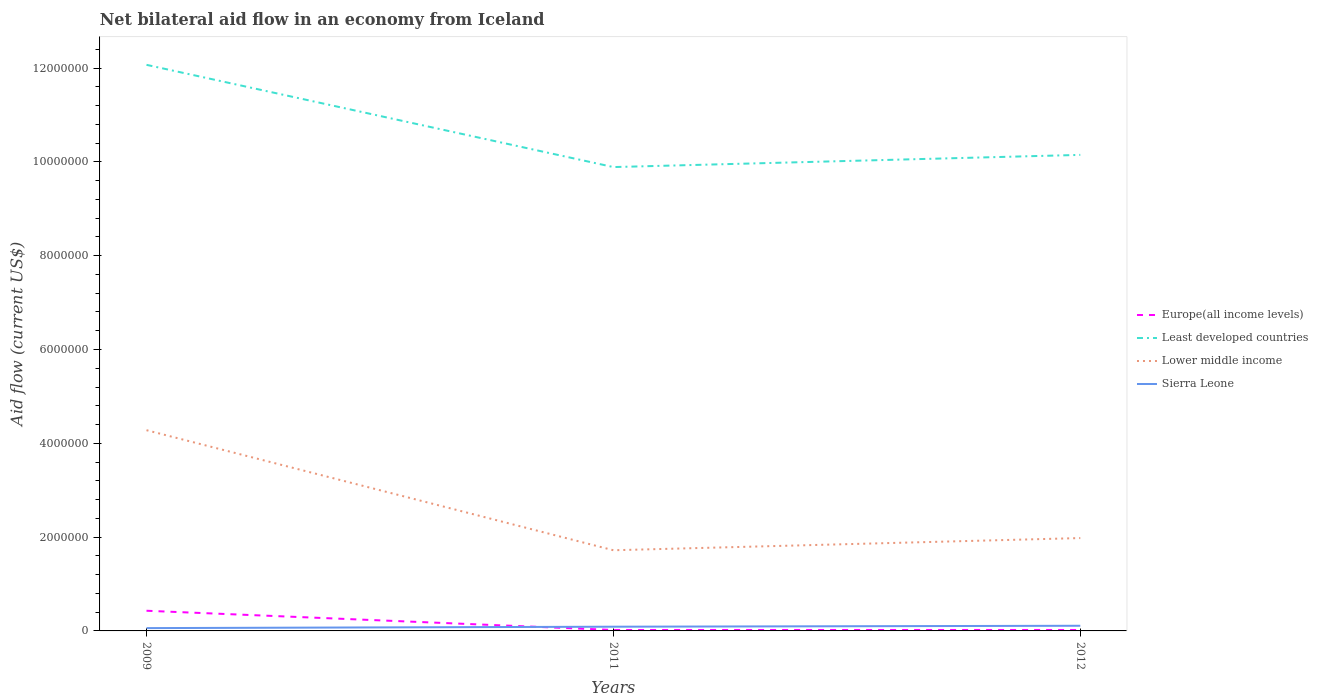Is the number of lines equal to the number of legend labels?
Offer a very short reply. Yes. What is the total net bilateral aid flow in Least developed countries in the graph?
Make the answer very short. 2.18e+06. What is the difference between the highest and the second highest net bilateral aid flow in Europe(all income levels)?
Give a very brief answer. 4.10e+05. What is the difference between the highest and the lowest net bilateral aid flow in Europe(all income levels)?
Ensure brevity in your answer.  1. How many years are there in the graph?
Make the answer very short. 3. Are the values on the major ticks of Y-axis written in scientific E-notation?
Your response must be concise. No. Does the graph contain any zero values?
Give a very brief answer. No. Does the graph contain grids?
Your answer should be compact. No. Where does the legend appear in the graph?
Ensure brevity in your answer.  Center right. How are the legend labels stacked?
Offer a terse response. Vertical. What is the title of the graph?
Make the answer very short. Net bilateral aid flow in an economy from Iceland. What is the label or title of the X-axis?
Offer a very short reply. Years. What is the Aid flow (current US$) in Europe(all income levels) in 2009?
Your answer should be compact. 4.30e+05. What is the Aid flow (current US$) in Least developed countries in 2009?
Give a very brief answer. 1.21e+07. What is the Aid flow (current US$) of Lower middle income in 2009?
Ensure brevity in your answer.  4.28e+06. What is the Aid flow (current US$) of Sierra Leone in 2009?
Ensure brevity in your answer.  6.00e+04. What is the Aid flow (current US$) of Europe(all income levels) in 2011?
Your answer should be very brief. 2.00e+04. What is the Aid flow (current US$) in Least developed countries in 2011?
Offer a very short reply. 9.89e+06. What is the Aid flow (current US$) of Lower middle income in 2011?
Offer a terse response. 1.72e+06. What is the Aid flow (current US$) of Sierra Leone in 2011?
Keep it short and to the point. 9.00e+04. What is the Aid flow (current US$) of Least developed countries in 2012?
Keep it short and to the point. 1.02e+07. What is the Aid flow (current US$) of Lower middle income in 2012?
Ensure brevity in your answer.  1.98e+06. Across all years, what is the maximum Aid flow (current US$) in Europe(all income levels)?
Provide a short and direct response. 4.30e+05. Across all years, what is the maximum Aid flow (current US$) in Least developed countries?
Your answer should be compact. 1.21e+07. Across all years, what is the maximum Aid flow (current US$) in Lower middle income?
Keep it short and to the point. 4.28e+06. Across all years, what is the maximum Aid flow (current US$) in Sierra Leone?
Your answer should be very brief. 1.10e+05. Across all years, what is the minimum Aid flow (current US$) of Least developed countries?
Your response must be concise. 9.89e+06. Across all years, what is the minimum Aid flow (current US$) in Lower middle income?
Provide a short and direct response. 1.72e+06. Across all years, what is the minimum Aid flow (current US$) in Sierra Leone?
Your response must be concise. 6.00e+04. What is the total Aid flow (current US$) in Least developed countries in the graph?
Keep it short and to the point. 3.21e+07. What is the total Aid flow (current US$) of Lower middle income in the graph?
Your response must be concise. 7.98e+06. What is the difference between the Aid flow (current US$) in Europe(all income levels) in 2009 and that in 2011?
Keep it short and to the point. 4.10e+05. What is the difference between the Aid flow (current US$) of Least developed countries in 2009 and that in 2011?
Ensure brevity in your answer.  2.18e+06. What is the difference between the Aid flow (current US$) of Lower middle income in 2009 and that in 2011?
Keep it short and to the point. 2.56e+06. What is the difference between the Aid flow (current US$) of Sierra Leone in 2009 and that in 2011?
Make the answer very short. -3.00e+04. What is the difference between the Aid flow (current US$) of Europe(all income levels) in 2009 and that in 2012?
Provide a short and direct response. 4.10e+05. What is the difference between the Aid flow (current US$) in Least developed countries in 2009 and that in 2012?
Your answer should be compact. 1.92e+06. What is the difference between the Aid flow (current US$) of Lower middle income in 2009 and that in 2012?
Your answer should be compact. 2.30e+06. What is the difference between the Aid flow (current US$) of Europe(all income levels) in 2011 and that in 2012?
Provide a short and direct response. 0. What is the difference between the Aid flow (current US$) of Europe(all income levels) in 2009 and the Aid flow (current US$) of Least developed countries in 2011?
Offer a terse response. -9.46e+06. What is the difference between the Aid flow (current US$) in Europe(all income levels) in 2009 and the Aid flow (current US$) in Lower middle income in 2011?
Provide a succinct answer. -1.29e+06. What is the difference between the Aid flow (current US$) of Europe(all income levels) in 2009 and the Aid flow (current US$) of Sierra Leone in 2011?
Ensure brevity in your answer.  3.40e+05. What is the difference between the Aid flow (current US$) of Least developed countries in 2009 and the Aid flow (current US$) of Lower middle income in 2011?
Your answer should be very brief. 1.04e+07. What is the difference between the Aid flow (current US$) of Least developed countries in 2009 and the Aid flow (current US$) of Sierra Leone in 2011?
Give a very brief answer. 1.20e+07. What is the difference between the Aid flow (current US$) in Lower middle income in 2009 and the Aid flow (current US$) in Sierra Leone in 2011?
Offer a very short reply. 4.19e+06. What is the difference between the Aid flow (current US$) in Europe(all income levels) in 2009 and the Aid flow (current US$) in Least developed countries in 2012?
Provide a succinct answer. -9.72e+06. What is the difference between the Aid flow (current US$) of Europe(all income levels) in 2009 and the Aid flow (current US$) of Lower middle income in 2012?
Your answer should be very brief. -1.55e+06. What is the difference between the Aid flow (current US$) in Europe(all income levels) in 2009 and the Aid flow (current US$) in Sierra Leone in 2012?
Provide a short and direct response. 3.20e+05. What is the difference between the Aid flow (current US$) of Least developed countries in 2009 and the Aid flow (current US$) of Lower middle income in 2012?
Your answer should be very brief. 1.01e+07. What is the difference between the Aid flow (current US$) of Least developed countries in 2009 and the Aid flow (current US$) of Sierra Leone in 2012?
Make the answer very short. 1.20e+07. What is the difference between the Aid flow (current US$) in Lower middle income in 2009 and the Aid flow (current US$) in Sierra Leone in 2012?
Ensure brevity in your answer.  4.17e+06. What is the difference between the Aid flow (current US$) of Europe(all income levels) in 2011 and the Aid flow (current US$) of Least developed countries in 2012?
Offer a terse response. -1.01e+07. What is the difference between the Aid flow (current US$) in Europe(all income levels) in 2011 and the Aid flow (current US$) in Lower middle income in 2012?
Provide a short and direct response. -1.96e+06. What is the difference between the Aid flow (current US$) of Least developed countries in 2011 and the Aid flow (current US$) of Lower middle income in 2012?
Make the answer very short. 7.91e+06. What is the difference between the Aid flow (current US$) of Least developed countries in 2011 and the Aid flow (current US$) of Sierra Leone in 2012?
Ensure brevity in your answer.  9.78e+06. What is the difference between the Aid flow (current US$) of Lower middle income in 2011 and the Aid flow (current US$) of Sierra Leone in 2012?
Offer a terse response. 1.61e+06. What is the average Aid flow (current US$) of Europe(all income levels) per year?
Offer a terse response. 1.57e+05. What is the average Aid flow (current US$) in Least developed countries per year?
Your answer should be compact. 1.07e+07. What is the average Aid flow (current US$) of Lower middle income per year?
Offer a very short reply. 2.66e+06. What is the average Aid flow (current US$) in Sierra Leone per year?
Make the answer very short. 8.67e+04. In the year 2009, what is the difference between the Aid flow (current US$) in Europe(all income levels) and Aid flow (current US$) in Least developed countries?
Make the answer very short. -1.16e+07. In the year 2009, what is the difference between the Aid flow (current US$) in Europe(all income levels) and Aid flow (current US$) in Lower middle income?
Make the answer very short. -3.85e+06. In the year 2009, what is the difference between the Aid flow (current US$) of Europe(all income levels) and Aid flow (current US$) of Sierra Leone?
Your response must be concise. 3.70e+05. In the year 2009, what is the difference between the Aid flow (current US$) of Least developed countries and Aid flow (current US$) of Lower middle income?
Offer a terse response. 7.79e+06. In the year 2009, what is the difference between the Aid flow (current US$) in Least developed countries and Aid flow (current US$) in Sierra Leone?
Keep it short and to the point. 1.20e+07. In the year 2009, what is the difference between the Aid flow (current US$) of Lower middle income and Aid flow (current US$) of Sierra Leone?
Provide a succinct answer. 4.22e+06. In the year 2011, what is the difference between the Aid flow (current US$) of Europe(all income levels) and Aid flow (current US$) of Least developed countries?
Your response must be concise. -9.87e+06. In the year 2011, what is the difference between the Aid flow (current US$) of Europe(all income levels) and Aid flow (current US$) of Lower middle income?
Provide a succinct answer. -1.70e+06. In the year 2011, what is the difference between the Aid flow (current US$) of Least developed countries and Aid flow (current US$) of Lower middle income?
Provide a succinct answer. 8.17e+06. In the year 2011, what is the difference between the Aid flow (current US$) in Least developed countries and Aid flow (current US$) in Sierra Leone?
Give a very brief answer. 9.80e+06. In the year 2011, what is the difference between the Aid flow (current US$) of Lower middle income and Aid flow (current US$) of Sierra Leone?
Your answer should be compact. 1.63e+06. In the year 2012, what is the difference between the Aid flow (current US$) of Europe(all income levels) and Aid flow (current US$) of Least developed countries?
Provide a succinct answer. -1.01e+07. In the year 2012, what is the difference between the Aid flow (current US$) of Europe(all income levels) and Aid flow (current US$) of Lower middle income?
Keep it short and to the point. -1.96e+06. In the year 2012, what is the difference between the Aid flow (current US$) in Least developed countries and Aid flow (current US$) in Lower middle income?
Your response must be concise. 8.17e+06. In the year 2012, what is the difference between the Aid flow (current US$) in Least developed countries and Aid flow (current US$) in Sierra Leone?
Offer a very short reply. 1.00e+07. In the year 2012, what is the difference between the Aid flow (current US$) of Lower middle income and Aid flow (current US$) of Sierra Leone?
Make the answer very short. 1.87e+06. What is the ratio of the Aid flow (current US$) of Least developed countries in 2009 to that in 2011?
Make the answer very short. 1.22. What is the ratio of the Aid flow (current US$) in Lower middle income in 2009 to that in 2011?
Your answer should be very brief. 2.49. What is the ratio of the Aid flow (current US$) in Least developed countries in 2009 to that in 2012?
Offer a very short reply. 1.19. What is the ratio of the Aid flow (current US$) in Lower middle income in 2009 to that in 2012?
Give a very brief answer. 2.16. What is the ratio of the Aid flow (current US$) in Sierra Leone in 2009 to that in 2012?
Provide a succinct answer. 0.55. What is the ratio of the Aid flow (current US$) in Europe(all income levels) in 2011 to that in 2012?
Your answer should be compact. 1. What is the ratio of the Aid flow (current US$) of Least developed countries in 2011 to that in 2012?
Make the answer very short. 0.97. What is the ratio of the Aid flow (current US$) of Lower middle income in 2011 to that in 2012?
Your response must be concise. 0.87. What is the ratio of the Aid flow (current US$) in Sierra Leone in 2011 to that in 2012?
Your answer should be compact. 0.82. What is the difference between the highest and the second highest Aid flow (current US$) of Least developed countries?
Ensure brevity in your answer.  1.92e+06. What is the difference between the highest and the second highest Aid flow (current US$) in Lower middle income?
Give a very brief answer. 2.30e+06. What is the difference between the highest and the lowest Aid flow (current US$) of Least developed countries?
Provide a short and direct response. 2.18e+06. What is the difference between the highest and the lowest Aid flow (current US$) in Lower middle income?
Keep it short and to the point. 2.56e+06. 